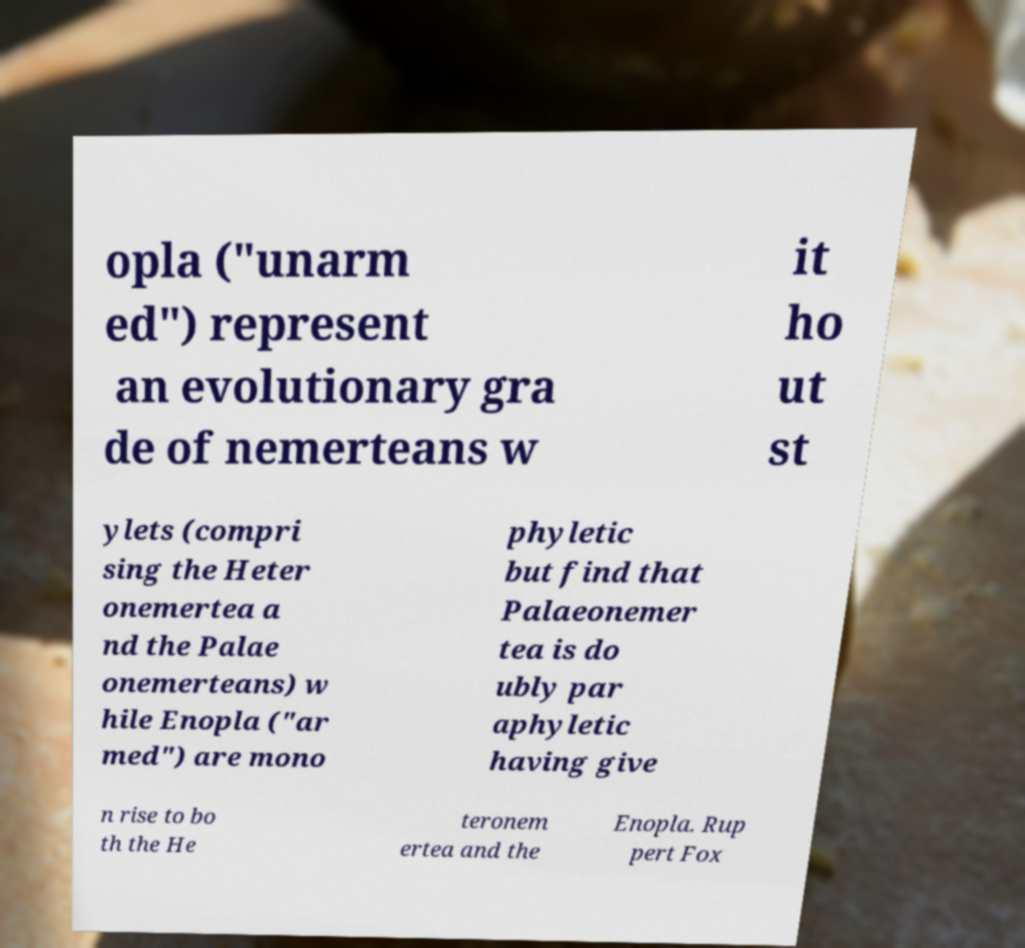I need the written content from this picture converted into text. Can you do that? opla ("unarm ed") represent an evolutionary gra de of nemerteans w it ho ut st ylets (compri sing the Heter onemertea a nd the Palae onemerteans) w hile Enopla ("ar med") are mono phyletic but find that Palaeonemer tea is do ubly par aphyletic having give n rise to bo th the He teronem ertea and the Enopla. Rup pert Fox 